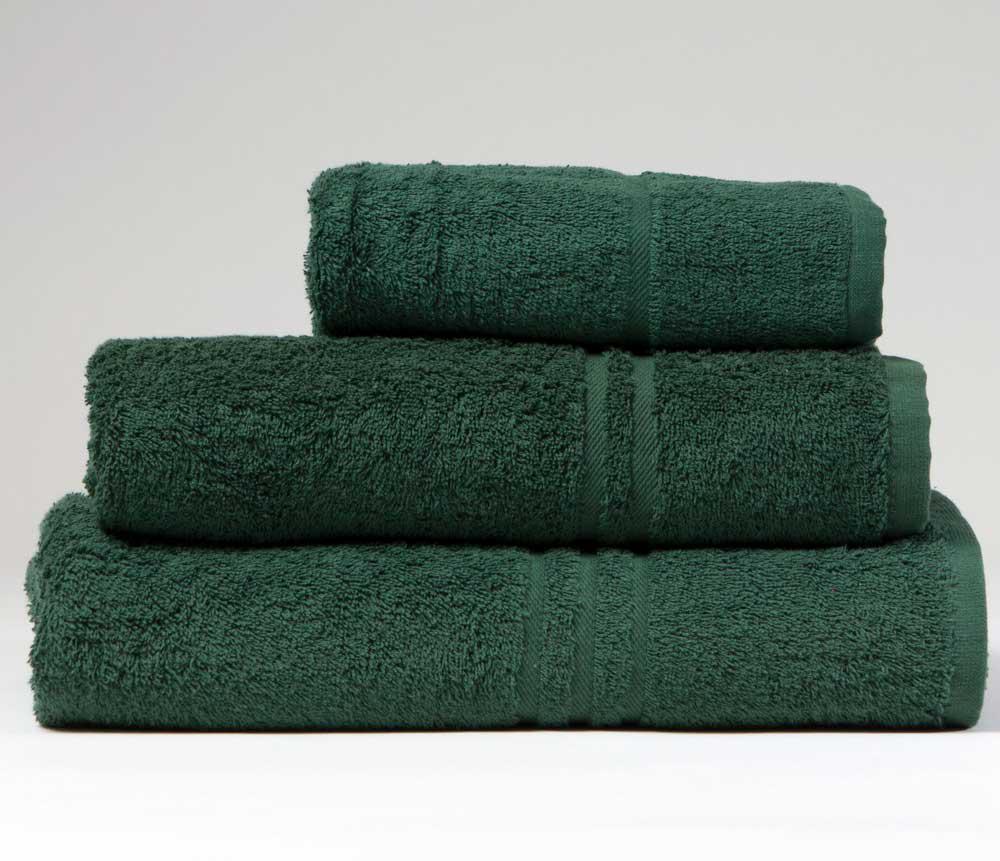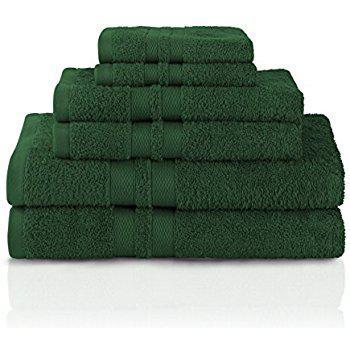The first image is the image on the left, the second image is the image on the right. Analyze the images presented: Is the assertion "In one image there are six green towels." valid? Answer yes or no. Yes. The first image is the image on the left, the second image is the image on the right. Evaluate the accuracy of this statement regarding the images: "There are exactly six towels in the right image.". Is it true? Answer yes or no. Yes. 